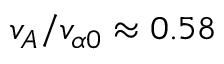<formula> <loc_0><loc_0><loc_500><loc_500>v _ { A } / v _ { \alpha 0 } \approx 0 . 5 8</formula> 